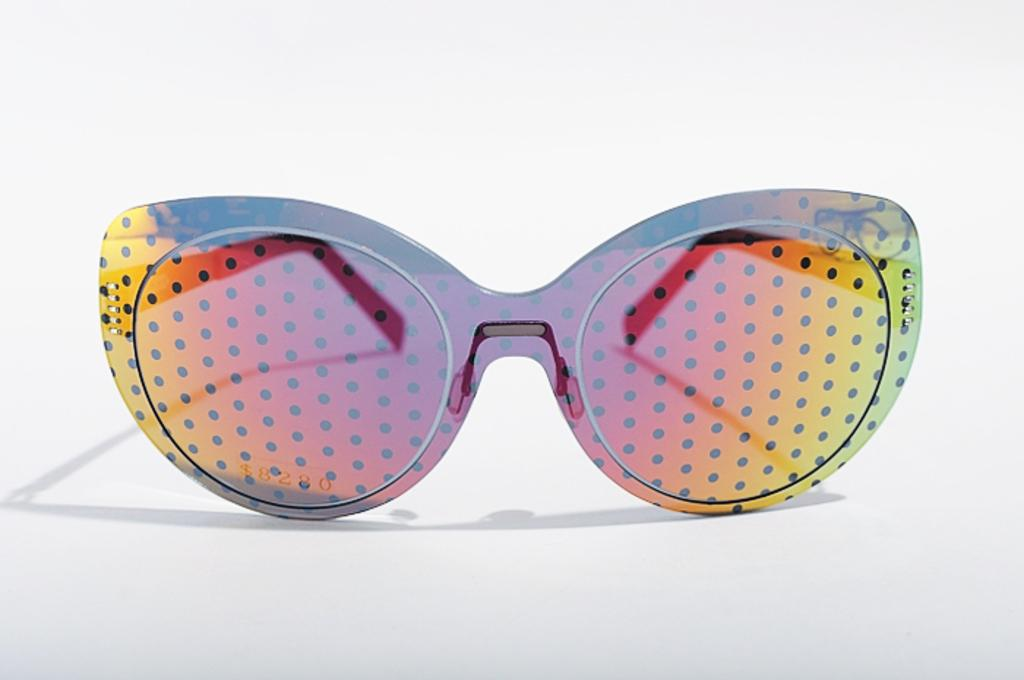What type of accessory is present in the image? There are goggles in the image. What distinguishing feature can be seen on the goggles? The goggles have different colored dots on them. What color is the background of the image? The background of the image is white. How many friends are visible in the image? There are no friends present in the image; it only features goggles with colored dots on a white background. 